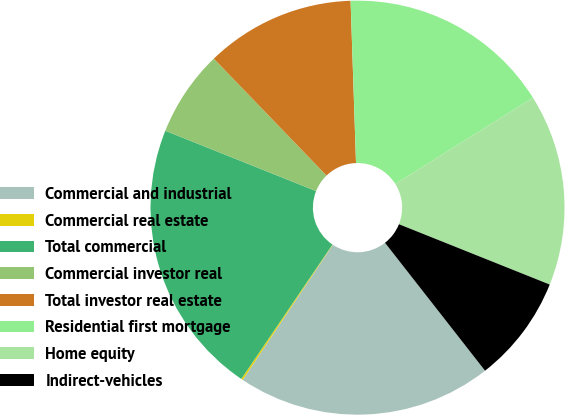<chart> <loc_0><loc_0><loc_500><loc_500><pie_chart><fcel>Commercial and industrial<fcel>Commercial real estate<fcel>Total commercial<fcel>Commercial investor real<fcel>Total investor real estate<fcel>Residential first mortgage<fcel>Home equity<fcel>Indirect-vehicles<nl><fcel>19.92%<fcel>0.13%<fcel>21.57%<fcel>6.73%<fcel>11.68%<fcel>16.62%<fcel>14.97%<fcel>8.38%<nl></chart> 